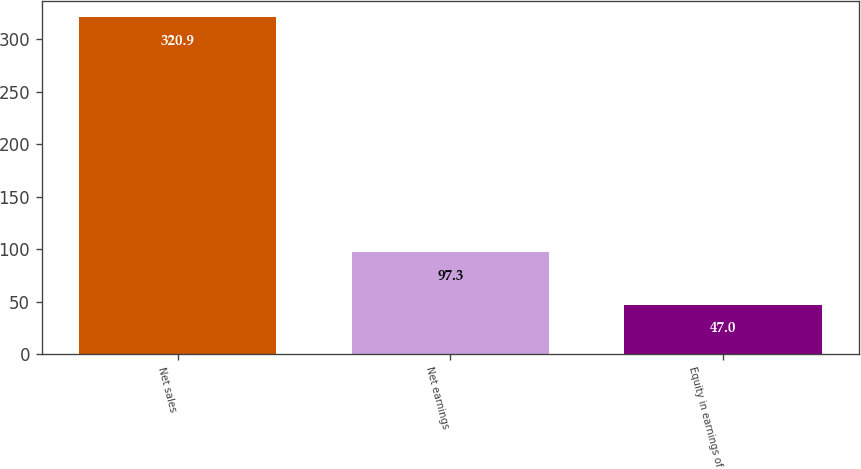Convert chart to OTSL. <chart><loc_0><loc_0><loc_500><loc_500><bar_chart><fcel>Net sales<fcel>Net earnings<fcel>Equity in earnings of<nl><fcel>320.9<fcel>97.3<fcel>47<nl></chart> 